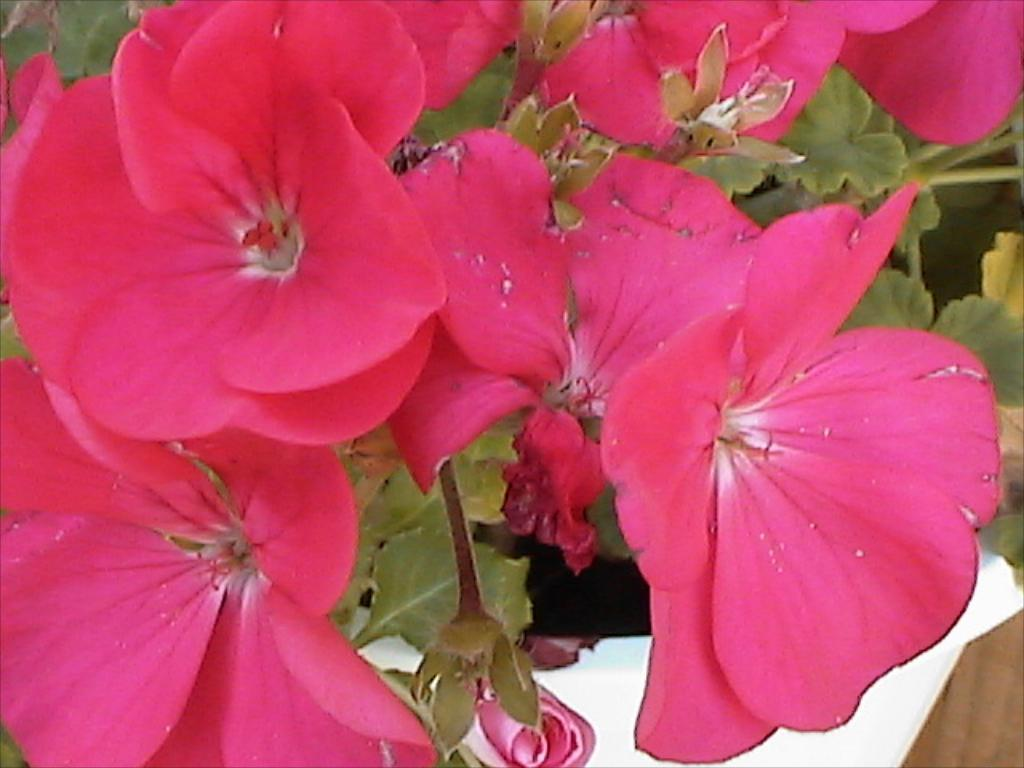What type of flowers can be seen in the image? There are pink flowers in the image. What else is present in the image besides the flowers? There are leaves and a white cloth in the image. What type of food is being cooked in the image? There is no food present in the image; it features pink flowers, leaves, and a white cloth. 